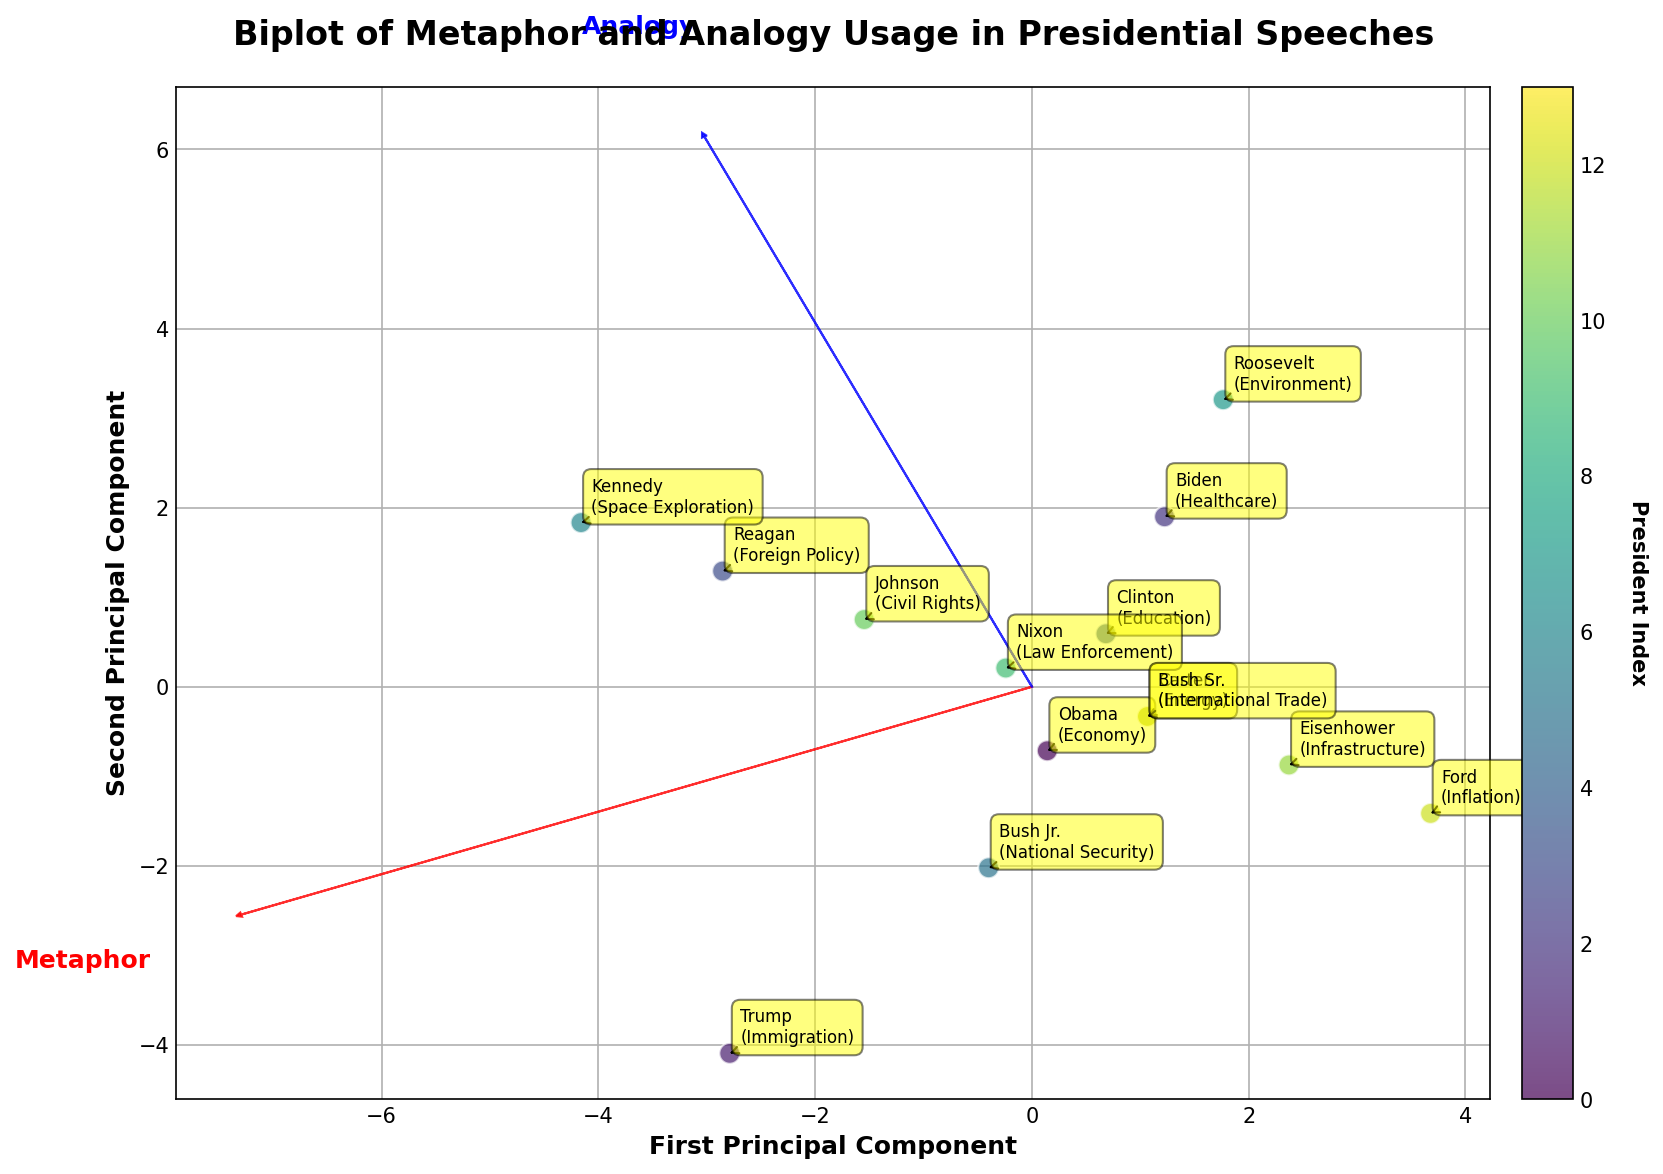what is the title of the figure? To determine the title, look at the top of the plot. The title is usually placed there for immediate identification of the figure's content. In this case, the title is clearly stated above the visual representation.
Answer: Biplot of Metaphor and Analogy Usage in Presidential Speeches how many policy areas are represented in the plot? Count the different annotations tied to each point in the plot, which indicate the different policy areas discussed by various presidents. There is one annotation per policy area.
Answer: 14 which president has the highest frequency of metaphors in their speeches? Look at the points in the plot and identify the one that is farthest along the Metaphor axis. The correct data point will correspond to the president with the highest metaphors usage, and the annotation by the point indicates the president.
Answer: Trump which two policy areas have the closest values for both metaphor and analogy frequencies? Identify pairs of points that visually appear close to each other on the plot. After finding closely spaced points, check their annotations to determine their policy areas.
Answer: Economy and Law Enforcement which axis explains more variation in the data? Check the arrows that represent the principal components. The length of the arrows indicates the amount of variation each component explains. The longer the arrow, the more variation it explains.
Answer: First Principal Component which president is represented by a point closest to the origin (0,0)? Identify the data point that is closest to the intersection of the x and y axes at (0,0). Check the corresponding annotation for the president.
Answer: Eisenhower compare the frequency of analogies used by Biden and Reagan. Who uses more? Find the data points representing Biden and Reagan. Check their positions on the Analogy axis and see which one is higher.
Answer: Reagan what color represents the data point for Nixon? Look at the color bar that shows the association between colors and data points. Find the color corresponding to Nixon's data point.
Answer: Yellow what is depicted by the arrows in the plot? Observe the arrows extending from the origin. They represent the directions and relative importance of the features, which are metaphor and analogy frequencies. The arrows’ lengths indicate the extent to which each feature contributes to the principal components.
Answer: Feature vectors for metaphor and analogy are metaphors or analogies more frequently used by presidents discussing foreign policy? Identify the point for Foreign Policy and check its positions on both Metaphor and Analogy axes. Compare the values to determine which is higher.
Answer: Analogies 